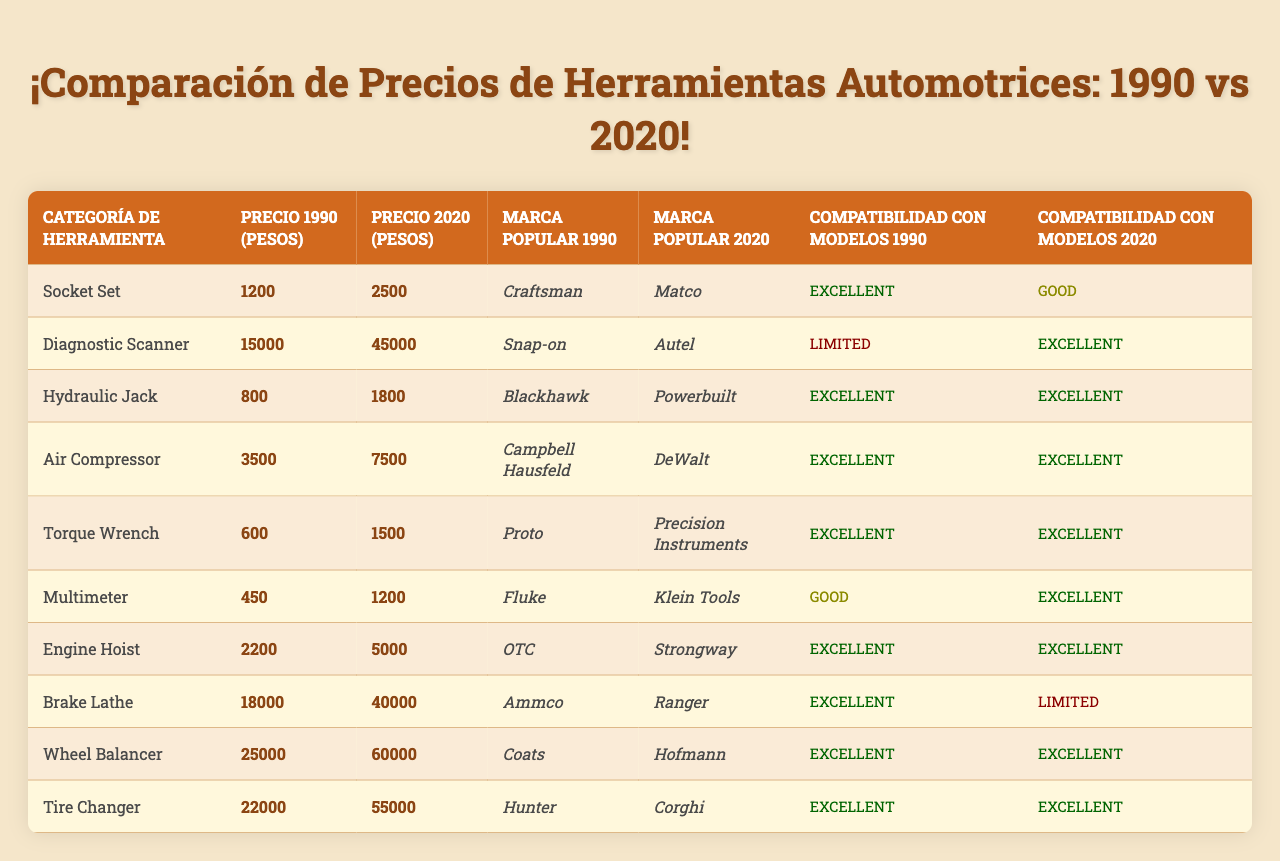What was the price of a Socket Set in 1990? In the table, under the "1990 Price (Pesos)" column for "Socket Set," the value is 1200.
Answer: 1200 What is the difference in price for the Hydraulic Jack between 1990 and 2020? For the Hydraulic Jack, the price in 1990 is 800, and in 2020 it is 1800. The difference is 1800 - 800 = 1000.
Answer: 1000 Which tool had the highest price increase from 1990 to 2020? By examining the price differences for all tools, the Tire Changer had the highest increase: 60000 - 22000 = 38000.
Answer: Tire Changer Is there a tool that remained the same price from 1990 to 2020? Checking all the price columns for any matching values, no tool shows the same price in both years, indicating all had price changes.
Answer: No What was the popular brand for the Air Compressor in 1990? Referring to the "Popular Brand in 1990" column, the Air Compressor is associated with the brand "Campbell Hausfeld."
Answer: Campbell Hausfeld Which tool had limited compatibility with 1990 models? The "Compatibility with 1990 Models" column shows that the Diagnostic Scanner had "Limited" compatibility.
Answer: Diagnostic Scanner What is the average price of tools in 2020? Summing the prices in the "2020 Price (Pesos)" column gives 2500 + 45000 + 1800 + 7500 + 1500 + 1200 + 5000 + 40000 + 60000 + 55000 = 144500; dividing by 10 gives an average of 14450.
Answer: 14450 Which tool has the best compatibility with 2020 models? "Excellent" compatibility indicates the Diagnostic Scanner, Hydraulic Jack, Air Compressor, Torque Wrench, Multimeter, Engine Hoist, Tire Changer, and Wheel Balancer, all fall in this category.
Answer: Multiple tools (e.g., Diagnostic Scanner, Hydraulic Jack) What was the price of the Brake Lathe in 1990? The "1990 Price (Pesos)" column shows that the Brake Lathe was priced at 18000.
Answer: 18000 Is the Torque Wrench more expensive in 2020 compared to 1990? The Torque Wrench price in 2020 is 1500 while in 1990 it was 600, indicating it is indeed more expensive now.
Answer: Yes 